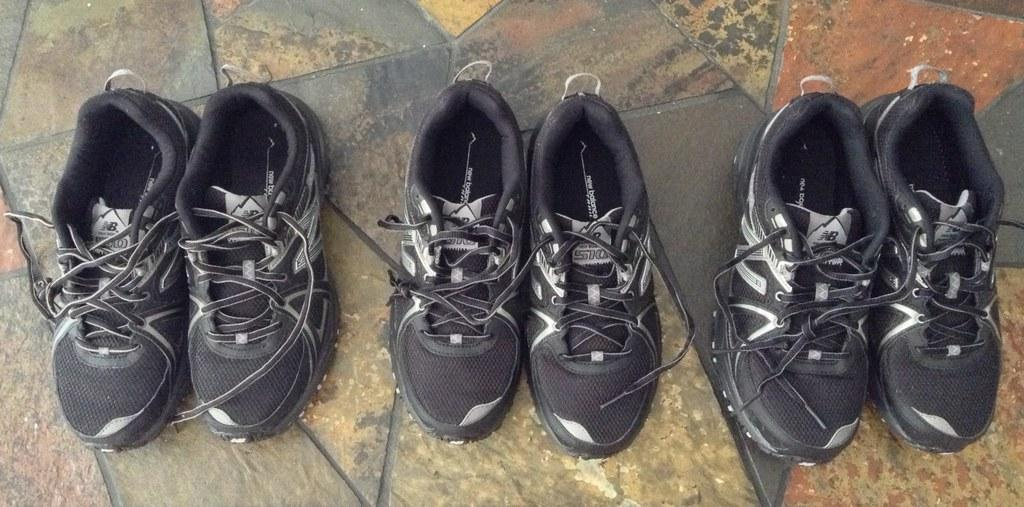How many pairs of shoes are visible in the image? There are three pairs of shoes in the image. Where are the shoes located? The shoes are on the floor. What type of fish can be seen swimming in the field near the shoes? There is no fish or field present in the image; it only features three pairs of shoes on the floor. 